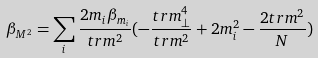<formula> <loc_0><loc_0><loc_500><loc_500>\beta _ { M ^ { 2 } } = \sum _ { i } \frac { 2 m _ { i } \beta _ { m _ { i } } } { t r m ^ { 2 } } ( - \frac { t r m _ { \perp } ^ { 4 } } { t r m ^ { 2 } } + 2 m _ { i } ^ { 2 } - \frac { 2 t r m ^ { 2 } } { N } )</formula> 